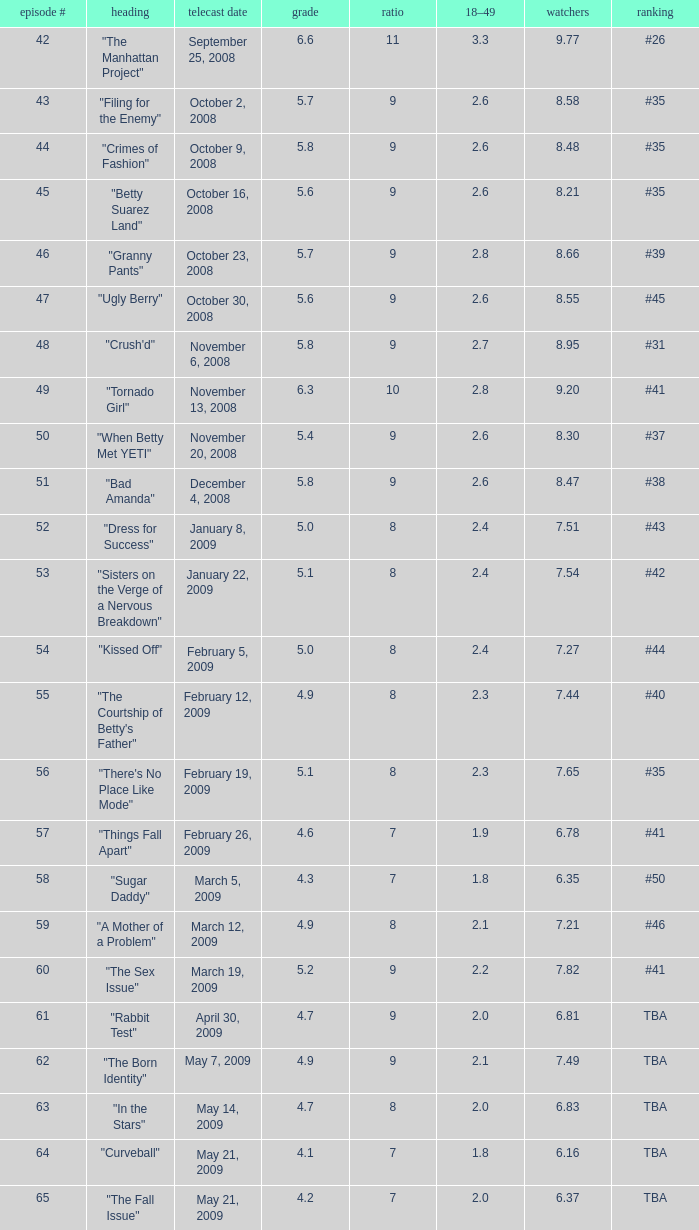Would you mind parsing the complete table? {'header': ['episode #', 'heading', 'telecast date', 'grade', 'ratio', '18–49', 'watchers', 'ranking'], 'rows': [['42', '"The Manhattan Project"', 'September 25, 2008', '6.6', '11', '3.3', '9.77', '#26'], ['43', '"Filing for the Enemy"', 'October 2, 2008', '5.7', '9', '2.6', '8.58', '#35'], ['44', '"Crimes of Fashion"', 'October 9, 2008', '5.8', '9', '2.6', '8.48', '#35'], ['45', '"Betty Suarez Land"', 'October 16, 2008', '5.6', '9', '2.6', '8.21', '#35'], ['46', '"Granny Pants"', 'October 23, 2008', '5.7', '9', '2.8', '8.66', '#39'], ['47', '"Ugly Berry"', 'October 30, 2008', '5.6', '9', '2.6', '8.55', '#45'], ['48', '"Crush\'d"', 'November 6, 2008', '5.8', '9', '2.7', '8.95', '#31'], ['49', '"Tornado Girl"', 'November 13, 2008', '6.3', '10', '2.8', '9.20', '#41'], ['50', '"When Betty Met YETI"', 'November 20, 2008', '5.4', '9', '2.6', '8.30', '#37'], ['51', '"Bad Amanda"', 'December 4, 2008', '5.8', '9', '2.6', '8.47', '#38'], ['52', '"Dress for Success"', 'January 8, 2009', '5.0', '8', '2.4', '7.51', '#43'], ['53', '"Sisters on the Verge of a Nervous Breakdown"', 'January 22, 2009', '5.1', '8', '2.4', '7.54', '#42'], ['54', '"Kissed Off"', 'February 5, 2009', '5.0', '8', '2.4', '7.27', '#44'], ['55', '"The Courtship of Betty\'s Father"', 'February 12, 2009', '4.9', '8', '2.3', '7.44', '#40'], ['56', '"There\'s No Place Like Mode"', 'February 19, 2009', '5.1', '8', '2.3', '7.65', '#35'], ['57', '"Things Fall Apart"', 'February 26, 2009', '4.6', '7', '1.9', '6.78', '#41'], ['58', '"Sugar Daddy"', 'March 5, 2009', '4.3', '7', '1.8', '6.35', '#50'], ['59', '"A Mother of a Problem"', 'March 12, 2009', '4.9', '8', '2.1', '7.21', '#46'], ['60', '"The Sex Issue"', 'March 19, 2009', '5.2', '9', '2.2', '7.82', '#41'], ['61', '"Rabbit Test"', 'April 30, 2009', '4.7', '9', '2.0', '6.81', 'TBA'], ['62', '"The Born Identity"', 'May 7, 2009', '4.9', '9', '2.1', '7.49', 'TBA'], ['63', '"In the Stars"', 'May 14, 2009', '4.7', '8', '2.0', '6.83', 'TBA'], ['64', '"Curveball"', 'May 21, 2009', '4.1', '7', '1.8', '6.16', 'TBA'], ['65', '"The Fall Issue"', 'May 21, 2009', '4.2', '7', '2.0', '6.37', 'TBA']]} What is the Air Date that has a 18–49 larger than 1.9, less than 7.54 viewers and a rating less than 4.9? April 30, 2009, May 14, 2009, May 21, 2009. 